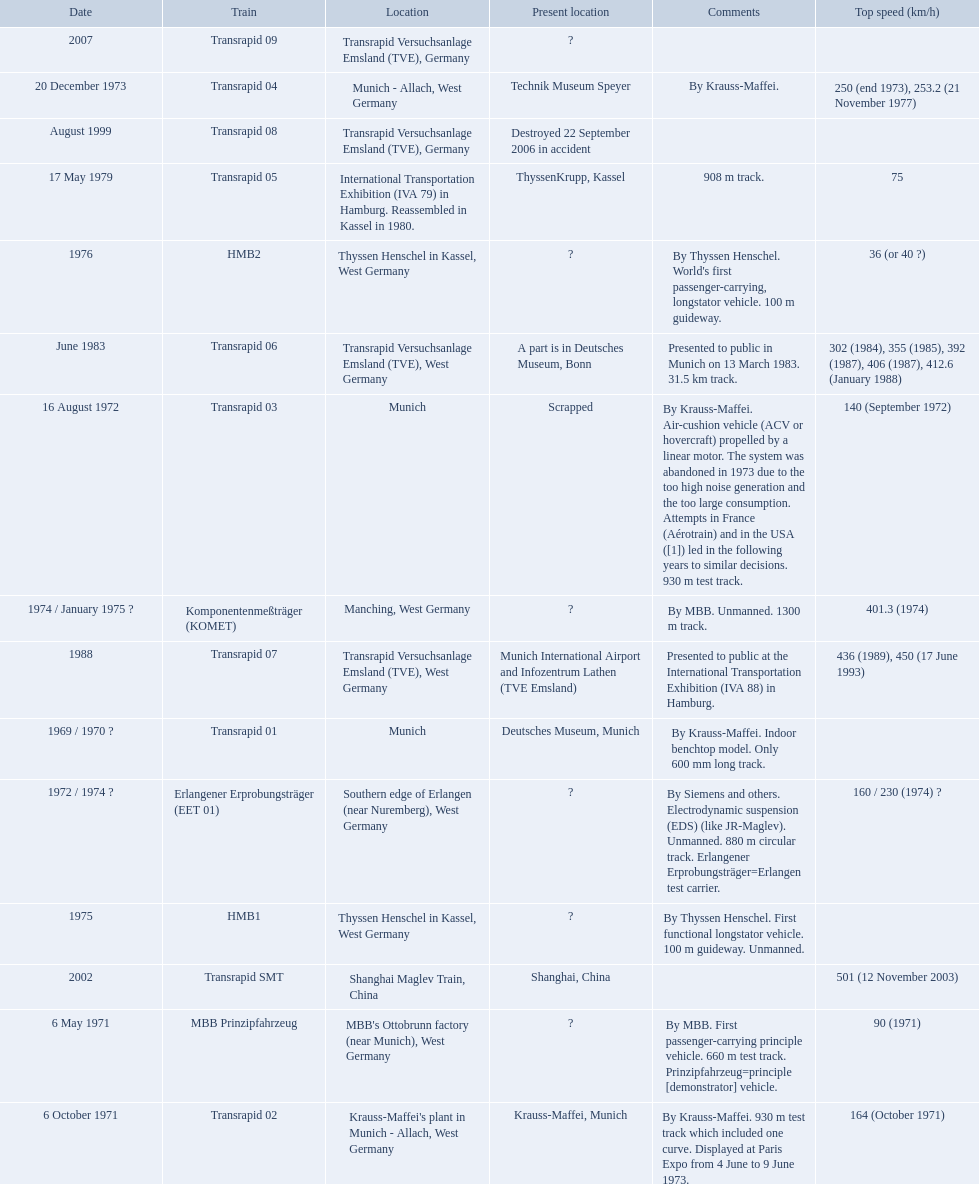What are all of the transrapid trains? Transrapid 01, Transrapid 02, Transrapid 03, Transrapid 04, Transrapid 05, Transrapid 06, Transrapid 07, Transrapid 08, Transrapid SMT, Transrapid 09. Of those, which train had to be scrapped? Transrapid 03. 